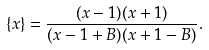<formula> <loc_0><loc_0><loc_500><loc_500>\{ x \} = \frac { ( x - 1 ) ( x + 1 ) } { ( x - 1 + B ) ( x + 1 - B ) } .</formula> 